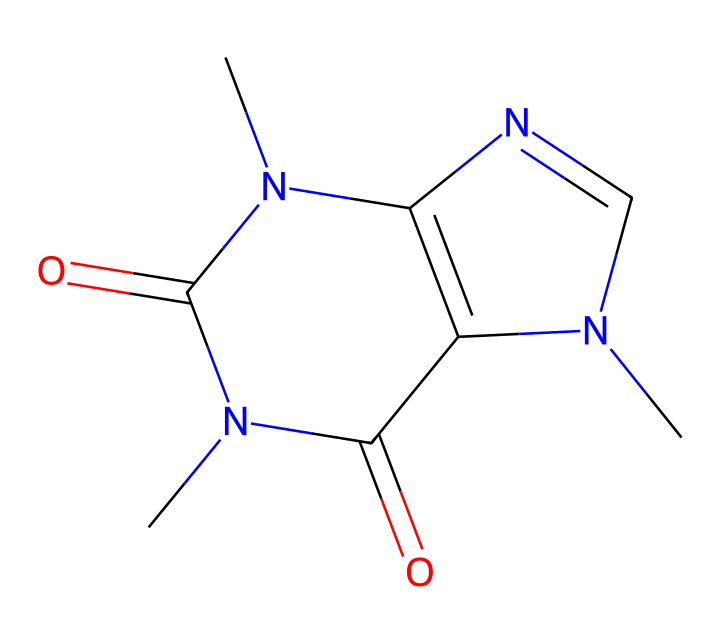what is the name of this chemical? This chemical's SMILES representation corresponds to caffeine, which is recognized as a common stimulant found in energy drinks and coffee.
Answer: caffeine how many carbon atoms are in this structure? By analyzing the chemical structure, there are a total of 8 carbon atoms present in the structure of caffeine, as indicated by the carbon symbols in the SMILES format.
Answer: 8 how many nitrogen atoms are present? In the provided SMILES representation, there are 4 nitrogen atoms present in the structure of caffeine, which contributes to its classification as an alkaloid.
Answer: 4 which functional group is present in this chemical? The structure shows two carbonyl (ketone) groups, indicated by the C=O bonds present in the SMILES, representing a significant functional group in caffeine.
Answer: carbonyl what type of chemical is caffeine classified as? Caffeine is classified as an alkaloid due to the presence of nitrogen atoms and its biological effects, which is characteristic of this category of compounds.
Answer: alkaloid what is the molecular formula of caffeine? The molecular formula of caffeine derived from its structure is C8H10N4O2, representing the sum of all the atoms present in the compound indicated by the SMILES.
Answer: C8H10N4O2 what is the type of bonds present in this chemical? The structure of caffeine contains single and double bonds; specifically, it has both C-C (single) and C=O (double) bonds, indicating its diverse bonding characteristics.
Answer: single and double bonds 